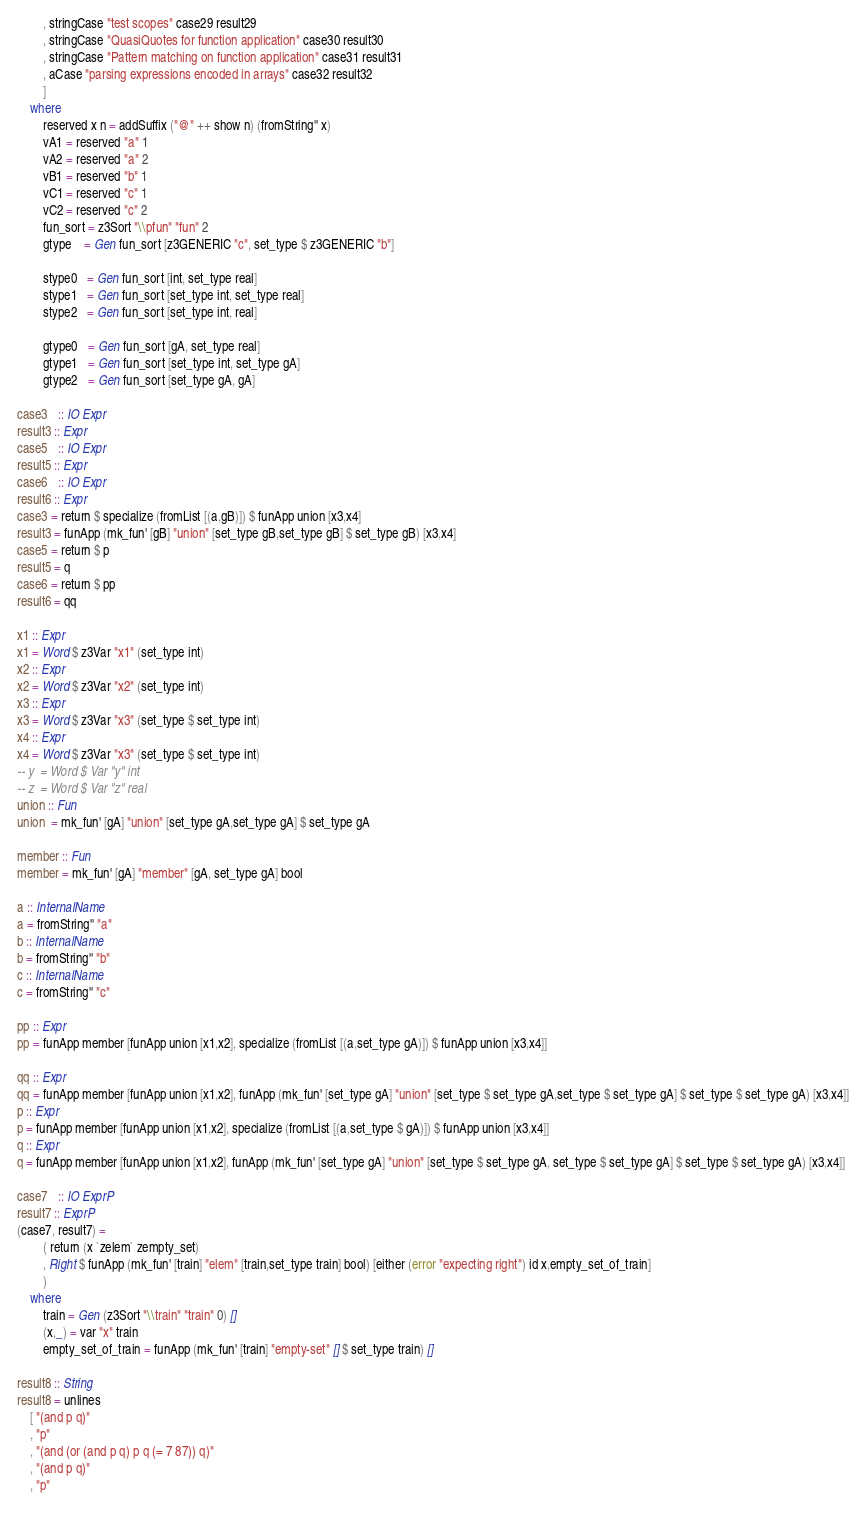Convert code to text. <code><loc_0><loc_0><loc_500><loc_500><_Haskell_>        , stringCase "test scopes" case29 result29
        , stringCase "QuasiQuotes for function application" case30 result30
        , stringCase "Pattern matching on function application" case31 result31
        , aCase "parsing expressions encoded in arrays" case32 result32
        ]
    where
        reserved x n = addSuffix ("@" ++ show n) (fromString'' x)
        vA1 = reserved "a" 1
        vA2 = reserved "a" 2
        vB1 = reserved "b" 1
        vC1 = reserved "c" 1
        vC2 = reserved "c" 2
        fun_sort = z3Sort "\\pfun" "fun" 2
        gtype    = Gen fun_sort [z3GENERIC "c", set_type $ z3GENERIC "b"]
        
        stype0   = Gen fun_sort [int, set_type real]
        stype1   = Gen fun_sort [set_type int, set_type real]
        stype2   = Gen fun_sort [set_type int, real]
        
        gtype0   = Gen fun_sort [gA, set_type real]
        gtype1   = Gen fun_sort [set_type int, set_type gA]
        gtype2   = Gen fun_sort [set_type gA, gA]

case3   :: IO Expr
result3 :: Expr
case5   :: IO Expr
result5 :: Expr
case6   :: IO Expr
result6 :: Expr
case3 = return $ specialize (fromList [(a,gB)]) $ funApp union [x3,x4]
result3 = funApp (mk_fun' [gB] "union" [set_type gB,set_type gB] $ set_type gB) [x3,x4] 
case5 = return $ p
result5 = q
case6 = return $ pp
result6 = qq

x1 :: Expr
x1 = Word $ z3Var "x1" (set_type int)
x2 :: Expr
x2 = Word $ z3Var "x2" (set_type int)
x3 :: Expr
x3 = Word $ z3Var "x3" (set_type $ set_type int)
x4 :: Expr
x4 = Word $ z3Var "x3" (set_type $ set_type int)
-- y  = Word $ Var "y" int
-- z  = Word $ Var "z" real
union :: Fun
union  = mk_fun' [gA] "union" [set_type gA,set_type gA] $ set_type gA

member :: Fun
member = mk_fun' [gA] "member" [gA, set_type gA] bool

a :: InternalName
a = fromString'' "a"
b :: InternalName
b = fromString'' "b"
c :: InternalName
c = fromString'' "c"

pp :: Expr
pp = funApp member [funApp union [x1,x2], specialize (fromList [(a,set_type gA)]) $ funApp union [x3,x4]]

qq :: Expr
qq = funApp member [funApp union [x1,x2], funApp (mk_fun' [set_type gA] "union" [set_type $ set_type gA,set_type $ set_type gA] $ set_type $ set_type gA) [x3,x4]]
p :: Expr
p = funApp member [funApp union [x1,x2], specialize (fromList [(a,set_type $ gA)]) $ funApp union [x3,x4]]
q :: Expr
q = funApp member [funApp union [x1,x2], funApp (mk_fun' [set_type gA] "union" [set_type $ set_type gA, set_type $ set_type gA] $ set_type $ set_type gA) [x3,x4]]

case7   :: IO ExprP
result7 :: ExprP
(case7, result7) = 
        ( return (x `zelem` zempty_set)
        , Right $ funApp (mk_fun' [train] "elem" [train,set_type train] bool) [either (error "expecting right") id x,empty_set_of_train]
        )
    where
        train = Gen (z3Sort "\\train" "train" 0) []
        (x,_) = var "x" train
        empty_set_of_train = funApp (mk_fun' [train] "empty-set" [] $ set_type train) []

result8 :: String
result8 = unlines
    [ "(and p q)"
    , "p"
    , "(and (or (and p q) p q (= 7 87)) q)"
    , "(and p q)"
    , "p"</code> 